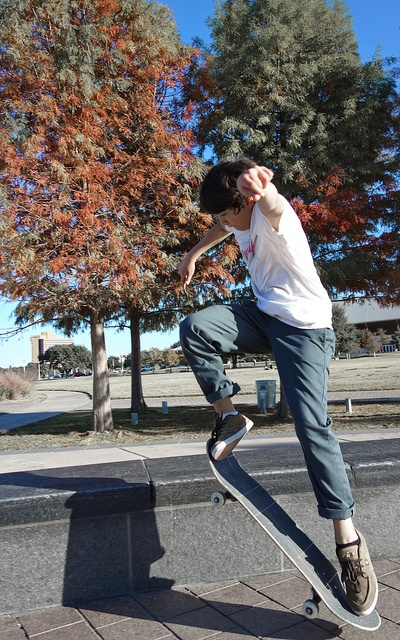Describe the objects in this image and their specific colors. I can see people in gray, black, darkgray, and white tones and skateboard in gray, black, darkgray, and navy tones in this image. 